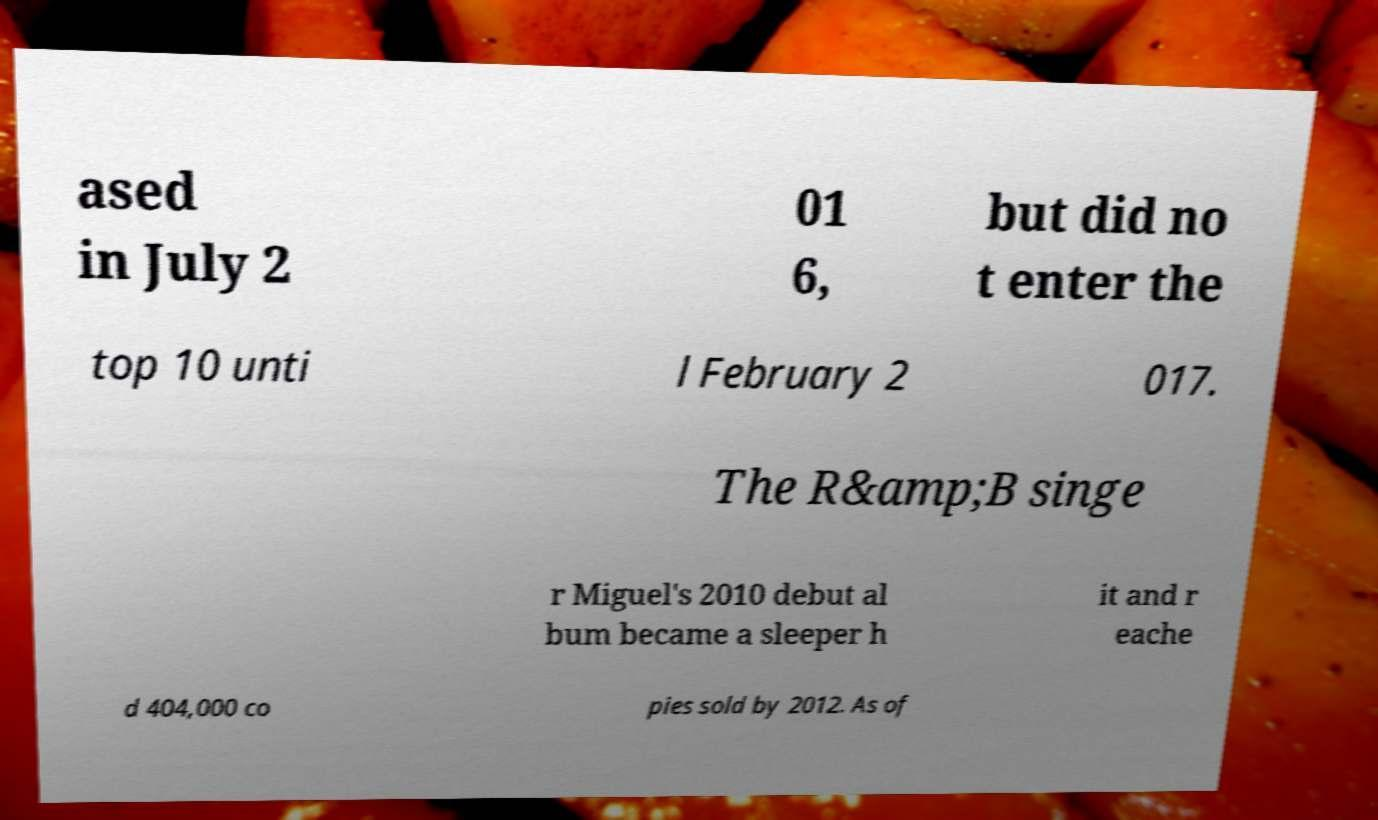For documentation purposes, I need the text within this image transcribed. Could you provide that? ased in July 2 01 6, but did no t enter the top 10 unti l February 2 017. The R&amp;B singe r Miguel's 2010 debut al bum became a sleeper h it and r eache d 404,000 co pies sold by 2012. As of 